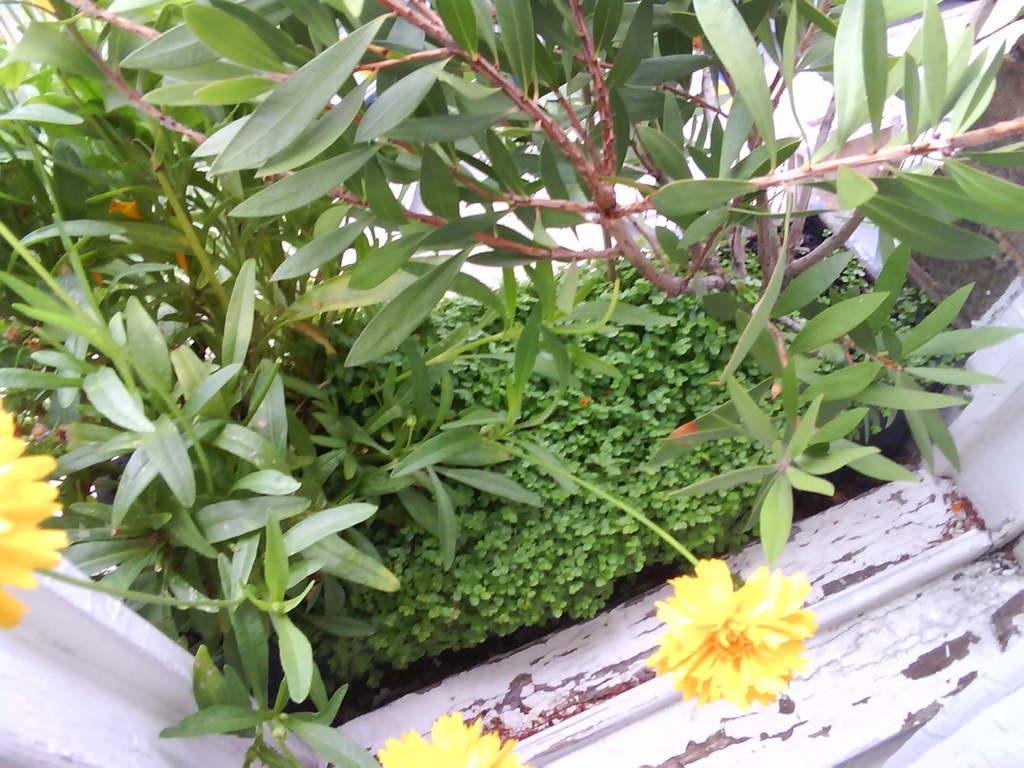Could you give a brief overview of what you see in this image? In this image we can see some plants and yellow color flowers. 